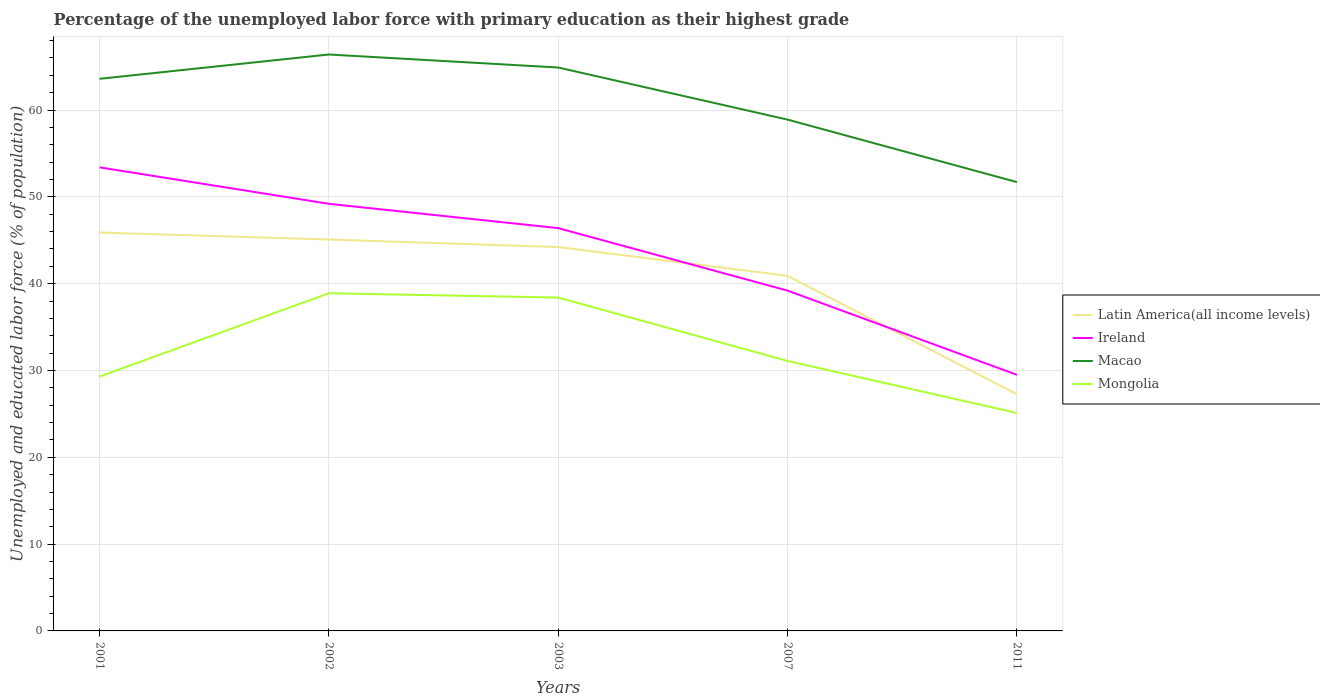How many different coloured lines are there?
Keep it short and to the point. 4. Is the number of lines equal to the number of legend labels?
Keep it short and to the point. Yes. Across all years, what is the maximum percentage of the unemployed labor force with primary education in Mongolia?
Your answer should be very brief. 25.1. What is the total percentage of the unemployed labor force with primary education in Ireland in the graph?
Provide a short and direct response. 19.7. What is the difference between the highest and the second highest percentage of the unemployed labor force with primary education in Latin America(all income levels)?
Offer a terse response. 18.63. Is the percentage of the unemployed labor force with primary education in Mongolia strictly greater than the percentage of the unemployed labor force with primary education in Latin America(all income levels) over the years?
Offer a very short reply. Yes. How many lines are there?
Offer a very short reply. 4. How many years are there in the graph?
Keep it short and to the point. 5. What is the title of the graph?
Keep it short and to the point. Percentage of the unemployed labor force with primary education as their highest grade. What is the label or title of the Y-axis?
Give a very brief answer. Unemployed and educated labor force (% of population). What is the Unemployed and educated labor force (% of population) in Latin America(all income levels) in 2001?
Ensure brevity in your answer.  45.89. What is the Unemployed and educated labor force (% of population) in Ireland in 2001?
Your answer should be compact. 53.4. What is the Unemployed and educated labor force (% of population) of Macao in 2001?
Provide a short and direct response. 63.6. What is the Unemployed and educated labor force (% of population) of Mongolia in 2001?
Offer a very short reply. 29.3. What is the Unemployed and educated labor force (% of population) of Latin America(all income levels) in 2002?
Give a very brief answer. 45.09. What is the Unemployed and educated labor force (% of population) in Ireland in 2002?
Ensure brevity in your answer.  49.2. What is the Unemployed and educated labor force (% of population) of Macao in 2002?
Provide a succinct answer. 66.4. What is the Unemployed and educated labor force (% of population) in Mongolia in 2002?
Offer a very short reply. 38.9. What is the Unemployed and educated labor force (% of population) of Latin America(all income levels) in 2003?
Your answer should be compact. 44.22. What is the Unemployed and educated labor force (% of population) in Ireland in 2003?
Provide a succinct answer. 46.4. What is the Unemployed and educated labor force (% of population) of Macao in 2003?
Give a very brief answer. 64.9. What is the Unemployed and educated labor force (% of population) in Mongolia in 2003?
Your answer should be very brief. 38.4. What is the Unemployed and educated labor force (% of population) of Latin America(all income levels) in 2007?
Ensure brevity in your answer.  40.9. What is the Unemployed and educated labor force (% of population) of Ireland in 2007?
Your response must be concise. 39.2. What is the Unemployed and educated labor force (% of population) in Macao in 2007?
Give a very brief answer. 58.9. What is the Unemployed and educated labor force (% of population) of Mongolia in 2007?
Your answer should be very brief. 31.1. What is the Unemployed and educated labor force (% of population) of Latin America(all income levels) in 2011?
Offer a terse response. 27.26. What is the Unemployed and educated labor force (% of population) in Ireland in 2011?
Ensure brevity in your answer.  29.5. What is the Unemployed and educated labor force (% of population) in Macao in 2011?
Offer a very short reply. 51.7. What is the Unemployed and educated labor force (% of population) in Mongolia in 2011?
Your response must be concise. 25.1. Across all years, what is the maximum Unemployed and educated labor force (% of population) of Latin America(all income levels)?
Keep it short and to the point. 45.89. Across all years, what is the maximum Unemployed and educated labor force (% of population) of Ireland?
Provide a short and direct response. 53.4. Across all years, what is the maximum Unemployed and educated labor force (% of population) of Macao?
Offer a terse response. 66.4. Across all years, what is the maximum Unemployed and educated labor force (% of population) of Mongolia?
Your answer should be compact. 38.9. Across all years, what is the minimum Unemployed and educated labor force (% of population) in Latin America(all income levels)?
Your answer should be very brief. 27.26. Across all years, what is the minimum Unemployed and educated labor force (% of population) in Ireland?
Provide a short and direct response. 29.5. Across all years, what is the minimum Unemployed and educated labor force (% of population) of Macao?
Offer a very short reply. 51.7. Across all years, what is the minimum Unemployed and educated labor force (% of population) of Mongolia?
Keep it short and to the point. 25.1. What is the total Unemployed and educated labor force (% of population) of Latin America(all income levels) in the graph?
Offer a very short reply. 203.36. What is the total Unemployed and educated labor force (% of population) in Ireland in the graph?
Provide a short and direct response. 217.7. What is the total Unemployed and educated labor force (% of population) in Macao in the graph?
Offer a very short reply. 305.5. What is the total Unemployed and educated labor force (% of population) of Mongolia in the graph?
Offer a very short reply. 162.8. What is the difference between the Unemployed and educated labor force (% of population) in Latin America(all income levels) in 2001 and that in 2002?
Offer a terse response. 0.8. What is the difference between the Unemployed and educated labor force (% of population) in Ireland in 2001 and that in 2002?
Provide a succinct answer. 4.2. What is the difference between the Unemployed and educated labor force (% of population) of Macao in 2001 and that in 2002?
Your answer should be compact. -2.8. What is the difference between the Unemployed and educated labor force (% of population) of Latin America(all income levels) in 2001 and that in 2003?
Make the answer very short. 1.67. What is the difference between the Unemployed and educated labor force (% of population) in Macao in 2001 and that in 2003?
Your response must be concise. -1.3. What is the difference between the Unemployed and educated labor force (% of population) in Latin America(all income levels) in 2001 and that in 2007?
Offer a very short reply. 4.99. What is the difference between the Unemployed and educated labor force (% of population) of Latin America(all income levels) in 2001 and that in 2011?
Your answer should be compact. 18.63. What is the difference between the Unemployed and educated labor force (% of population) of Ireland in 2001 and that in 2011?
Make the answer very short. 23.9. What is the difference between the Unemployed and educated labor force (% of population) in Latin America(all income levels) in 2002 and that in 2003?
Your answer should be compact. 0.87. What is the difference between the Unemployed and educated labor force (% of population) of Ireland in 2002 and that in 2003?
Your response must be concise. 2.8. What is the difference between the Unemployed and educated labor force (% of population) of Mongolia in 2002 and that in 2003?
Offer a terse response. 0.5. What is the difference between the Unemployed and educated labor force (% of population) in Latin America(all income levels) in 2002 and that in 2007?
Your answer should be compact. 4.18. What is the difference between the Unemployed and educated labor force (% of population) of Macao in 2002 and that in 2007?
Your response must be concise. 7.5. What is the difference between the Unemployed and educated labor force (% of population) of Mongolia in 2002 and that in 2007?
Offer a very short reply. 7.8. What is the difference between the Unemployed and educated labor force (% of population) in Latin America(all income levels) in 2002 and that in 2011?
Provide a short and direct response. 17.83. What is the difference between the Unemployed and educated labor force (% of population) of Ireland in 2002 and that in 2011?
Offer a very short reply. 19.7. What is the difference between the Unemployed and educated labor force (% of population) in Mongolia in 2002 and that in 2011?
Provide a succinct answer. 13.8. What is the difference between the Unemployed and educated labor force (% of population) of Latin America(all income levels) in 2003 and that in 2007?
Your response must be concise. 3.31. What is the difference between the Unemployed and educated labor force (% of population) of Mongolia in 2003 and that in 2007?
Your answer should be very brief. 7.3. What is the difference between the Unemployed and educated labor force (% of population) of Latin America(all income levels) in 2003 and that in 2011?
Provide a succinct answer. 16.96. What is the difference between the Unemployed and educated labor force (% of population) in Mongolia in 2003 and that in 2011?
Provide a succinct answer. 13.3. What is the difference between the Unemployed and educated labor force (% of population) of Latin America(all income levels) in 2007 and that in 2011?
Give a very brief answer. 13.65. What is the difference between the Unemployed and educated labor force (% of population) in Ireland in 2007 and that in 2011?
Provide a succinct answer. 9.7. What is the difference between the Unemployed and educated labor force (% of population) of Mongolia in 2007 and that in 2011?
Keep it short and to the point. 6. What is the difference between the Unemployed and educated labor force (% of population) in Latin America(all income levels) in 2001 and the Unemployed and educated labor force (% of population) in Ireland in 2002?
Provide a short and direct response. -3.31. What is the difference between the Unemployed and educated labor force (% of population) in Latin America(all income levels) in 2001 and the Unemployed and educated labor force (% of population) in Macao in 2002?
Offer a terse response. -20.51. What is the difference between the Unemployed and educated labor force (% of population) of Latin America(all income levels) in 2001 and the Unemployed and educated labor force (% of population) of Mongolia in 2002?
Give a very brief answer. 6.99. What is the difference between the Unemployed and educated labor force (% of population) of Ireland in 2001 and the Unemployed and educated labor force (% of population) of Macao in 2002?
Offer a terse response. -13. What is the difference between the Unemployed and educated labor force (% of population) of Ireland in 2001 and the Unemployed and educated labor force (% of population) of Mongolia in 2002?
Offer a terse response. 14.5. What is the difference between the Unemployed and educated labor force (% of population) of Macao in 2001 and the Unemployed and educated labor force (% of population) of Mongolia in 2002?
Provide a short and direct response. 24.7. What is the difference between the Unemployed and educated labor force (% of population) of Latin America(all income levels) in 2001 and the Unemployed and educated labor force (% of population) of Ireland in 2003?
Keep it short and to the point. -0.51. What is the difference between the Unemployed and educated labor force (% of population) in Latin America(all income levels) in 2001 and the Unemployed and educated labor force (% of population) in Macao in 2003?
Offer a very short reply. -19.01. What is the difference between the Unemployed and educated labor force (% of population) in Latin America(all income levels) in 2001 and the Unemployed and educated labor force (% of population) in Mongolia in 2003?
Keep it short and to the point. 7.49. What is the difference between the Unemployed and educated labor force (% of population) in Ireland in 2001 and the Unemployed and educated labor force (% of population) in Macao in 2003?
Offer a terse response. -11.5. What is the difference between the Unemployed and educated labor force (% of population) of Macao in 2001 and the Unemployed and educated labor force (% of population) of Mongolia in 2003?
Make the answer very short. 25.2. What is the difference between the Unemployed and educated labor force (% of population) in Latin America(all income levels) in 2001 and the Unemployed and educated labor force (% of population) in Ireland in 2007?
Your answer should be compact. 6.69. What is the difference between the Unemployed and educated labor force (% of population) of Latin America(all income levels) in 2001 and the Unemployed and educated labor force (% of population) of Macao in 2007?
Provide a succinct answer. -13.01. What is the difference between the Unemployed and educated labor force (% of population) of Latin America(all income levels) in 2001 and the Unemployed and educated labor force (% of population) of Mongolia in 2007?
Keep it short and to the point. 14.79. What is the difference between the Unemployed and educated labor force (% of population) of Ireland in 2001 and the Unemployed and educated labor force (% of population) of Mongolia in 2007?
Your answer should be very brief. 22.3. What is the difference between the Unemployed and educated labor force (% of population) in Macao in 2001 and the Unemployed and educated labor force (% of population) in Mongolia in 2007?
Make the answer very short. 32.5. What is the difference between the Unemployed and educated labor force (% of population) of Latin America(all income levels) in 2001 and the Unemployed and educated labor force (% of population) of Ireland in 2011?
Your response must be concise. 16.39. What is the difference between the Unemployed and educated labor force (% of population) of Latin America(all income levels) in 2001 and the Unemployed and educated labor force (% of population) of Macao in 2011?
Your answer should be very brief. -5.81. What is the difference between the Unemployed and educated labor force (% of population) of Latin America(all income levels) in 2001 and the Unemployed and educated labor force (% of population) of Mongolia in 2011?
Give a very brief answer. 20.79. What is the difference between the Unemployed and educated labor force (% of population) of Ireland in 2001 and the Unemployed and educated labor force (% of population) of Macao in 2011?
Your response must be concise. 1.7. What is the difference between the Unemployed and educated labor force (% of population) of Ireland in 2001 and the Unemployed and educated labor force (% of population) of Mongolia in 2011?
Your answer should be very brief. 28.3. What is the difference between the Unemployed and educated labor force (% of population) in Macao in 2001 and the Unemployed and educated labor force (% of population) in Mongolia in 2011?
Offer a very short reply. 38.5. What is the difference between the Unemployed and educated labor force (% of population) of Latin America(all income levels) in 2002 and the Unemployed and educated labor force (% of population) of Ireland in 2003?
Your answer should be very brief. -1.31. What is the difference between the Unemployed and educated labor force (% of population) in Latin America(all income levels) in 2002 and the Unemployed and educated labor force (% of population) in Macao in 2003?
Your answer should be compact. -19.81. What is the difference between the Unemployed and educated labor force (% of population) of Latin America(all income levels) in 2002 and the Unemployed and educated labor force (% of population) of Mongolia in 2003?
Ensure brevity in your answer.  6.69. What is the difference between the Unemployed and educated labor force (% of population) in Ireland in 2002 and the Unemployed and educated labor force (% of population) in Macao in 2003?
Your answer should be compact. -15.7. What is the difference between the Unemployed and educated labor force (% of population) in Latin America(all income levels) in 2002 and the Unemployed and educated labor force (% of population) in Ireland in 2007?
Your answer should be very brief. 5.89. What is the difference between the Unemployed and educated labor force (% of population) of Latin America(all income levels) in 2002 and the Unemployed and educated labor force (% of population) of Macao in 2007?
Provide a succinct answer. -13.81. What is the difference between the Unemployed and educated labor force (% of population) in Latin America(all income levels) in 2002 and the Unemployed and educated labor force (% of population) in Mongolia in 2007?
Provide a succinct answer. 13.99. What is the difference between the Unemployed and educated labor force (% of population) of Ireland in 2002 and the Unemployed and educated labor force (% of population) of Macao in 2007?
Keep it short and to the point. -9.7. What is the difference between the Unemployed and educated labor force (% of population) of Ireland in 2002 and the Unemployed and educated labor force (% of population) of Mongolia in 2007?
Make the answer very short. 18.1. What is the difference between the Unemployed and educated labor force (% of population) in Macao in 2002 and the Unemployed and educated labor force (% of population) in Mongolia in 2007?
Give a very brief answer. 35.3. What is the difference between the Unemployed and educated labor force (% of population) in Latin America(all income levels) in 2002 and the Unemployed and educated labor force (% of population) in Ireland in 2011?
Make the answer very short. 15.59. What is the difference between the Unemployed and educated labor force (% of population) of Latin America(all income levels) in 2002 and the Unemployed and educated labor force (% of population) of Macao in 2011?
Give a very brief answer. -6.61. What is the difference between the Unemployed and educated labor force (% of population) of Latin America(all income levels) in 2002 and the Unemployed and educated labor force (% of population) of Mongolia in 2011?
Your answer should be very brief. 19.99. What is the difference between the Unemployed and educated labor force (% of population) of Ireland in 2002 and the Unemployed and educated labor force (% of population) of Mongolia in 2011?
Give a very brief answer. 24.1. What is the difference between the Unemployed and educated labor force (% of population) of Macao in 2002 and the Unemployed and educated labor force (% of population) of Mongolia in 2011?
Ensure brevity in your answer.  41.3. What is the difference between the Unemployed and educated labor force (% of population) of Latin America(all income levels) in 2003 and the Unemployed and educated labor force (% of population) of Ireland in 2007?
Keep it short and to the point. 5.02. What is the difference between the Unemployed and educated labor force (% of population) in Latin America(all income levels) in 2003 and the Unemployed and educated labor force (% of population) in Macao in 2007?
Provide a succinct answer. -14.68. What is the difference between the Unemployed and educated labor force (% of population) of Latin America(all income levels) in 2003 and the Unemployed and educated labor force (% of population) of Mongolia in 2007?
Provide a succinct answer. 13.12. What is the difference between the Unemployed and educated labor force (% of population) of Ireland in 2003 and the Unemployed and educated labor force (% of population) of Macao in 2007?
Your response must be concise. -12.5. What is the difference between the Unemployed and educated labor force (% of population) in Ireland in 2003 and the Unemployed and educated labor force (% of population) in Mongolia in 2007?
Offer a terse response. 15.3. What is the difference between the Unemployed and educated labor force (% of population) in Macao in 2003 and the Unemployed and educated labor force (% of population) in Mongolia in 2007?
Keep it short and to the point. 33.8. What is the difference between the Unemployed and educated labor force (% of population) of Latin America(all income levels) in 2003 and the Unemployed and educated labor force (% of population) of Ireland in 2011?
Your answer should be compact. 14.72. What is the difference between the Unemployed and educated labor force (% of population) in Latin America(all income levels) in 2003 and the Unemployed and educated labor force (% of population) in Macao in 2011?
Provide a succinct answer. -7.48. What is the difference between the Unemployed and educated labor force (% of population) of Latin America(all income levels) in 2003 and the Unemployed and educated labor force (% of population) of Mongolia in 2011?
Your answer should be compact. 19.12. What is the difference between the Unemployed and educated labor force (% of population) in Ireland in 2003 and the Unemployed and educated labor force (% of population) in Macao in 2011?
Provide a short and direct response. -5.3. What is the difference between the Unemployed and educated labor force (% of population) in Ireland in 2003 and the Unemployed and educated labor force (% of population) in Mongolia in 2011?
Offer a terse response. 21.3. What is the difference between the Unemployed and educated labor force (% of population) of Macao in 2003 and the Unemployed and educated labor force (% of population) of Mongolia in 2011?
Keep it short and to the point. 39.8. What is the difference between the Unemployed and educated labor force (% of population) of Latin America(all income levels) in 2007 and the Unemployed and educated labor force (% of population) of Ireland in 2011?
Offer a terse response. 11.4. What is the difference between the Unemployed and educated labor force (% of population) of Latin America(all income levels) in 2007 and the Unemployed and educated labor force (% of population) of Macao in 2011?
Keep it short and to the point. -10.8. What is the difference between the Unemployed and educated labor force (% of population) in Latin America(all income levels) in 2007 and the Unemployed and educated labor force (% of population) in Mongolia in 2011?
Provide a short and direct response. 15.8. What is the difference between the Unemployed and educated labor force (% of population) of Ireland in 2007 and the Unemployed and educated labor force (% of population) of Macao in 2011?
Your response must be concise. -12.5. What is the difference between the Unemployed and educated labor force (% of population) of Macao in 2007 and the Unemployed and educated labor force (% of population) of Mongolia in 2011?
Keep it short and to the point. 33.8. What is the average Unemployed and educated labor force (% of population) in Latin America(all income levels) per year?
Your answer should be very brief. 40.67. What is the average Unemployed and educated labor force (% of population) in Ireland per year?
Ensure brevity in your answer.  43.54. What is the average Unemployed and educated labor force (% of population) of Macao per year?
Provide a succinct answer. 61.1. What is the average Unemployed and educated labor force (% of population) in Mongolia per year?
Ensure brevity in your answer.  32.56. In the year 2001, what is the difference between the Unemployed and educated labor force (% of population) in Latin America(all income levels) and Unemployed and educated labor force (% of population) in Ireland?
Your answer should be compact. -7.51. In the year 2001, what is the difference between the Unemployed and educated labor force (% of population) of Latin America(all income levels) and Unemployed and educated labor force (% of population) of Macao?
Your answer should be very brief. -17.71. In the year 2001, what is the difference between the Unemployed and educated labor force (% of population) of Latin America(all income levels) and Unemployed and educated labor force (% of population) of Mongolia?
Make the answer very short. 16.59. In the year 2001, what is the difference between the Unemployed and educated labor force (% of population) of Ireland and Unemployed and educated labor force (% of population) of Mongolia?
Make the answer very short. 24.1. In the year 2001, what is the difference between the Unemployed and educated labor force (% of population) of Macao and Unemployed and educated labor force (% of population) of Mongolia?
Make the answer very short. 34.3. In the year 2002, what is the difference between the Unemployed and educated labor force (% of population) in Latin America(all income levels) and Unemployed and educated labor force (% of population) in Ireland?
Your answer should be compact. -4.11. In the year 2002, what is the difference between the Unemployed and educated labor force (% of population) in Latin America(all income levels) and Unemployed and educated labor force (% of population) in Macao?
Your response must be concise. -21.31. In the year 2002, what is the difference between the Unemployed and educated labor force (% of population) of Latin America(all income levels) and Unemployed and educated labor force (% of population) of Mongolia?
Provide a short and direct response. 6.19. In the year 2002, what is the difference between the Unemployed and educated labor force (% of population) in Ireland and Unemployed and educated labor force (% of population) in Macao?
Provide a short and direct response. -17.2. In the year 2002, what is the difference between the Unemployed and educated labor force (% of population) of Macao and Unemployed and educated labor force (% of population) of Mongolia?
Make the answer very short. 27.5. In the year 2003, what is the difference between the Unemployed and educated labor force (% of population) of Latin America(all income levels) and Unemployed and educated labor force (% of population) of Ireland?
Provide a short and direct response. -2.18. In the year 2003, what is the difference between the Unemployed and educated labor force (% of population) of Latin America(all income levels) and Unemployed and educated labor force (% of population) of Macao?
Offer a terse response. -20.68. In the year 2003, what is the difference between the Unemployed and educated labor force (% of population) of Latin America(all income levels) and Unemployed and educated labor force (% of population) of Mongolia?
Your response must be concise. 5.82. In the year 2003, what is the difference between the Unemployed and educated labor force (% of population) of Ireland and Unemployed and educated labor force (% of population) of Macao?
Provide a succinct answer. -18.5. In the year 2003, what is the difference between the Unemployed and educated labor force (% of population) in Ireland and Unemployed and educated labor force (% of population) in Mongolia?
Offer a terse response. 8. In the year 2007, what is the difference between the Unemployed and educated labor force (% of population) of Latin America(all income levels) and Unemployed and educated labor force (% of population) of Ireland?
Give a very brief answer. 1.7. In the year 2007, what is the difference between the Unemployed and educated labor force (% of population) of Latin America(all income levels) and Unemployed and educated labor force (% of population) of Macao?
Your answer should be very brief. -18. In the year 2007, what is the difference between the Unemployed and educated labor force (% of population) in Latin America(all income levels) and Unemployed and educated labor force (% of population) in Mongolia?
Your answer should be compact. 9.8. In the year 2007, what is the difference between the Unemployed and educated labor force (% of population) in Ireland and Unemployed and educated labor force (% of population) in Macao?
Your response must be concise. -19.7. In the year 2007, what is the difference between the Unemployed and educated labor force (% of population) in Macao and Unemployed and educated labor force (% of population) in Mongolia?
Make the answer very short. 27.8. In the year 2011, what is the difference between the Unemployed and educated labor force (% of population) of Latin America(all income levels) and Unemployed and educated labor force (% of population) of Ireland?
Provide a succinct answer. -2.24. In the year 2011, what is the difference between the Unemployed and educated labor force (% of population) in Latin America(all income levels) and Unemployed and educated labor force (% of population) in Macao?
Your answer should be very brief. -24.44. In the year 2011, what is the difference between the Unemployed and educated labor force (% of population) in Latin America(all income levels) and Unemployed and educated labor force (% of population) in Mongolia?
Provide a succinct answer. 2.16. In the year 2011, what is the difference between the Unemployed and educated labor force (% of population) in Ireland and Unemployed and educated labor force (% of population) in Macao?
Keep it short and to the point. -22.2. In the year 2011, what is the difference between the Unemployed and educated labor force (% of population) in Macao and Unemployed and educated labor force (% of population) in Mongolia?
Your answer should be very brief. 26.6. What is the ratio of the Unemployed and educated labor force (% of population) in Latin America(all income levels) in 2001 to that in 2002?
Your answer should be very brief. 1.02. What is the ratio of the Unemployed and educated labor force (% of population) in Ireland in 2001 to that in 2002?
Ensure brevity in your answer.  1.09. What is the ratio of the Unemployed and educated labor force (% of population) of Macao in 2001 to that in 2002?
Your answer should be very brief. 0.96. What is the ratio of the Unemployed and educated labor force (% of population) of Mongolia in 2001 to that in 2002?
Offer a very short reply. 0.75. What is the ratio of the Unemployed and educated labor force (% of population) of Latin America(all income levels) in 2001 to that in 2003?
Offer a very short reply. 1.04. What is the ratio of the Unemployed and educated labor force (% of population) in Ireland in 2001 to that in 2003?
Provide a short and direct response. 1.15. What is the ratio of the Unemployed and educated labor force (% of population) in Mongolia in 2001 to that in 2003?
Your answer should be very brief. 0.76. What is the ratio of the Unemployed and educated labor force (% of population) in Latin America(all income levels) in 2001 to that in 2007?
Offer a terse response. 1.12. What is the ratio of the Unemployed and educated labor force (% of population) of Ireland in 2001 to that in 2007?
Ensure brevity in your answer.  1.36. What is the ratio of the Unemployed and educated labor force (% of population) of Macao in 2001 to that in 2007?
Keep it short and to the point. 1.08. What is the ratio of the Unemployed and educated labor force (% of population) of Mongolia in 2001 to that in 2007?
Offer a terse response. 0.94. What is the ratio of the Unemployed and educated labor force (% of population) of Latin America(all income levels) in 2001 to that in 2011?
Keep it short and to the point. 1.68. What is the ratio of the Unemployed and educated labor force (% of population) in Ireland in 2001 to that in 2011?
Offer a terse response. 1.81. What is the ratio of the Unemployed and educated labor force (% of population) of Macao in 2001 to that in 2011?
Offer a very short reply. 1.23. What is the ratio of the Unemployed and educated labor force (% of population) in Mongolia in 2001 to that in 2011?
Provide a succinct answer. 1.17. What is the ratio of the Unemployed and educated labor force (% of population) of Latin America(all income levels) in 2002 to that in 2003?
Make the answer very short. 1.02. What is the ratio of the Unemployed and educated labor force (% of population) of Ireland in 2002 to that in 2003?
Offer a terse response. 1.06. What is the ratio of the Unemployed and educated labor force (% of population) of Macao in 2002 to that in 2003?
Ensure brevity in your answer.  1.02. What is the ratio of the Unemployed and educated labor force (% of population) of Latin America(all income levels) in 2002 to that in 2007?
Offer a very short reply. 1.1. What is the ratio of the Unemployed and educated labor force (% of population) of Ireland in 2002 to that in 2007?
Give a very brief answer. 1.26. What is the ratio of the Unemployed and educated labor force (% of population) in Macao in 2002 to that in 2007?
Keep it short and to the point. 1.13. What is the ratio of the Unemployed and educated labor force (% of population) of Mongolia in 2002 to that in 2007?
Provide a succinct answer. 1.25. What is the ratio of the Unemployed and educated labor force (% of population) in Latin America(all income levels) in 2002 to that in 2011?
Your answer should be very brief. 1.65. What is the ratio of the Unemployed and educated labor force (% of population) of Ireland in 2002 to that in 2011?
Your response must be concise. 1.67. What is the ratio of the Unemployed and educated labor force (% of population) of Macao in 2002 to that in 2011?
Keep it short and to the point. 1.28. What is the ratio of the Unemployed and educated labor force (% of population) of Mongolia in 2002 to that in 2011?
Your answer should be compact. 1.55. What is the ratio of the Unemployed and educated labor force (% of population) of Latin America(all income levels) in 2003 to that in 2007?
Keep it short and to the point. 1.08. What is the ratio of the Unemployed and educated labor force (% of population) in Ireland in 2003 to that in 2007?
Provide a short and direct response. 1.18. What is the ratio of the Unemployed and educated labor force (% of population) in Macao in 2003 to that in 2007?
Your response must be concise. 1.1. What is the ratio of the Unemployed and educated labor force (% of population) of Mongolia in 2003 to that in 2007?
Provide a short and direct response. 1.23. What is the ratio of the Unemployed and educated labor force (% of population) in Latin America(all income levels) in 2003 to that in 2011?
Keep it short and to the point. 1.62. What is the ratio of the Unemployed and educated labor force (% of population) of Ireland in 2003 to that in 2011?
Offer a terse response. 1.57. What is the ratio of the Unemployed and educated labor force (% of population) of Macao in 2003 to that in 2011?
Make the answer very short. 1.26. What is the ratio of the Unemployed and educated labor force (% of population) in Mongolia in 2003 to that in 2011?
Provide a short and direct response. 1.53. What is the ratio of the Unemployed and educated labor force (% of population) in Latin America(all income levels) in 2007 to that in 2011?
Provide a short and direct response. 1.5. What is the ratio of the Unemployed and educated labor force (% of population) in Ireland in 2007 to that in 2011?
Offer a very short reply. 1.33. What is the ratio of the Unemployed and educated labor force (% of population) in Macao in 2007 to that in 2011?
Provide a short and direct response. 1.14. What is the ratio of the Unemployed and educated labor force (% of population) in Mongolia in 2007 to that in 2011?
Provide a succinct answer. 1.24. What is the difference between the highest and the second highest Unemployed and educated labor force (% of population) of Latin America(all income levels)?
Make the answer very short. 0.8. What is the difference between the highest and the second highest Unemployed and educated labor force (% of population) in Macao?
Your answer should be very brief. 1.5. What is the difference between the highest and the second highest Unemployed and educated labor force (% of population) of Mongolia?
Your answer should be compact. 0.5. What is the difference between the highest and the lowest Unemployed and educated labor force (% of population) of Latin America(all income levels)?
Your answer should be very brief. 18.63. What is the difference between the highest and the lowest Unemployed and educated labor force (% of population) in Ireland?
Your response must be concise. 23.9. What is the difference between the highest and the lowest Unemployed and educated labor force (% of population) of Macao?
Ensure brevity in your answer.  14.7. 